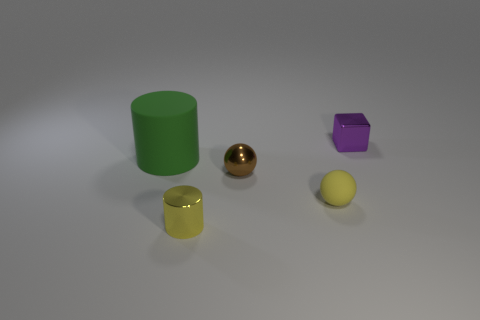The other thing that is the same shape as the big green object is what size?
Keep it short and to the point. Small. Do the tiny metal cube and the large thing have the same color?
Keep it short and to the point. No. How many other things are there of the same material as the purple cube?
Offer a terse response. 2. Are there an equal number of tiny cylinders that are right of the brown metal thing and large green cylinders?
Ensure brevity in your answer.  No. Does the cylinder on the left side of the yellow shiny thing have the same size as the tiny yellow rubber object?
Keep it short and to the point. No. There is a rubber cylinder; how many big green rubber cylinders are on the left side of it?
Provide a short and direct response. 0. There is a small object that is both to the right of the small brown metallic object and on the left side of the small block; what material is it?
Provide a succinct answer. Rubber. How many small objects are red metal things or yellow things?
Make the answer very short. 2. What is the size of the matte cylinder?
Make the answer very short. Large. The small yellow rubber thing is what shape?
Your answer should be compact. Sphere. 